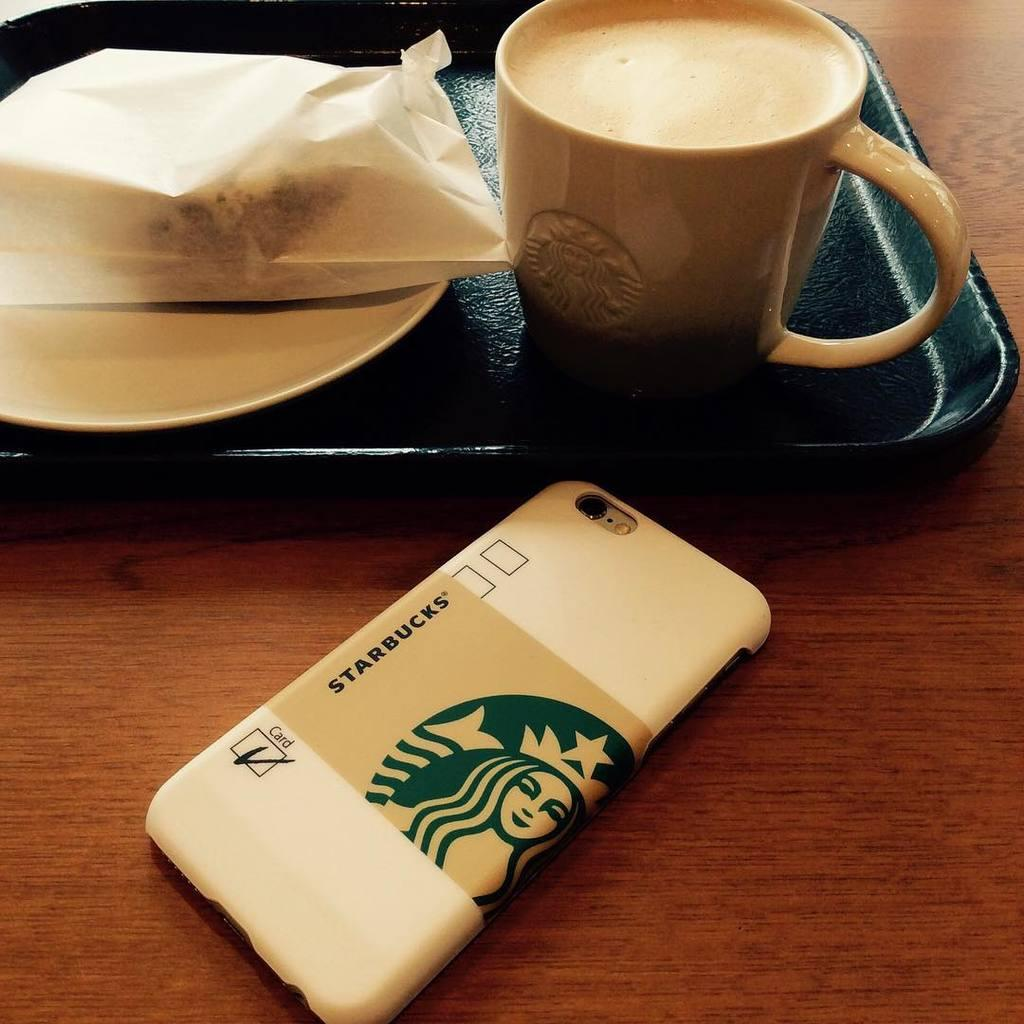<image>
Provide a brief description of the given image. Starbucks coffee and a starbucks phone case for a phone 